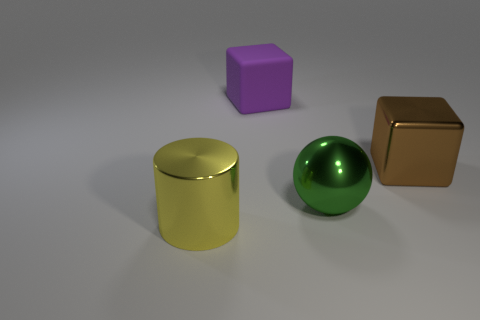There is a thing on the left side of the block that is on the left side of the brown cube; what size is it?
Keep it short and to the point. Large. What number of large blue metal objects are there?
Ensure brevity in your answer.  0. How many other green spheres are made of the same material as the big green sphere?
Offer a terse response. 0. What size is the purple thing that is the same shape as the large brown thing?
Your answer should be very brief. Large. What is the material of the big sphere?
Provide a succinct answer. Metal. There is a large green thing that is in front of the thing behind the thing that is to the right of the green shiny object; what is it made of?
Provide a succinct answer. Metal. Is there any other thing that has the same shape as the large yellow metallic thing?
Make the answer very short. No. What color is the other large object that is the same shape as the large matte thing?
Offer a terse response. Brown. Is the number of big shiny blocks that are to the right of the shiny block greater than the number of large cubes?
Keep it short and to the point. No. What number of other objects are there of the same size as the brown metallic object?
Your answer should be very brief. 3. 